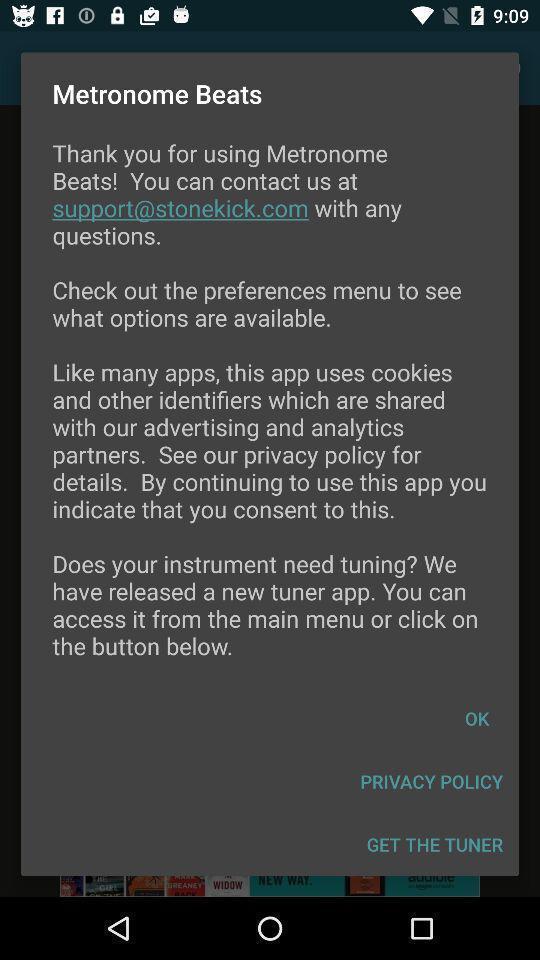Give me a summary of this screen capture. Pop-up showing welcome page. 